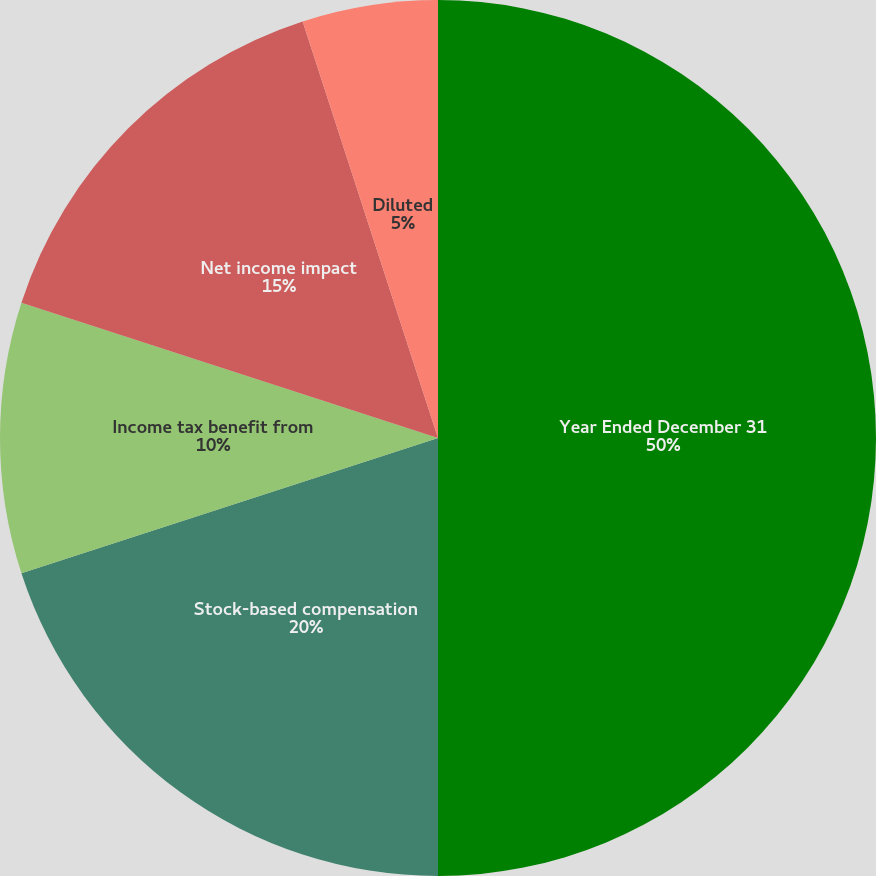Convert chart to OTSL. <chart><loc_0><loc_0><loc_500><loc_500><pie_chart><fcel>Year Ended December 31<fcel>Stock-based compensation<fcel>Income tax benefit from<fcel>Net income impact<fcel>Basic<fcel>Diluted<nl><fcel>50.0%<fcel>20.0%<fcel>10.0%<fcel>15.0%<fcel>0.0%<fcel>5.0%<nl></chart> 